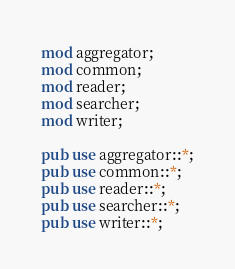Convert code to text. <code><loc_0><loc_0><loc_500><loc_500><_Rust_>mod aggregator;
mod common;
mod reader;
mod searcher;
mod writer;

pub use aggregator::*;
pub use common::*;
pub use reader::*;
pub use searcher::*;
pub use writer::*;
</code> 